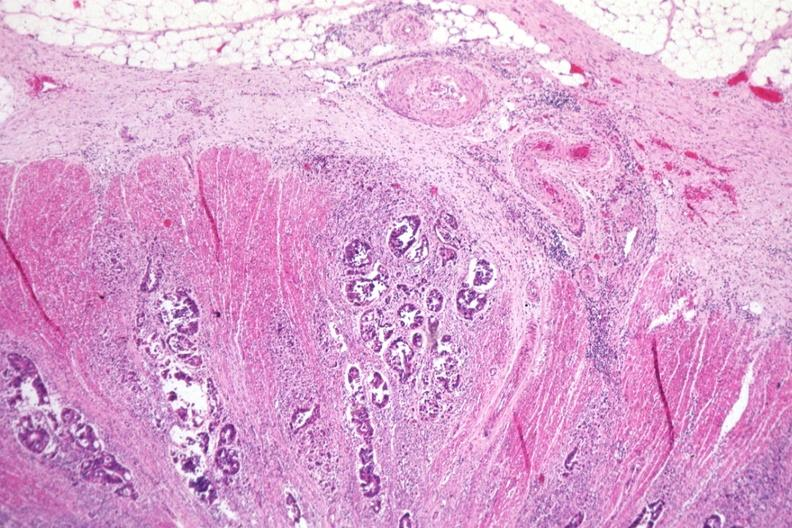where is this from?
Answer the question using a single word or phrase. Gastrointestinal system 